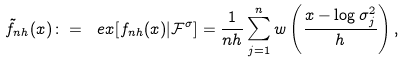Convert formula to latex. <formula><loc_0><loc_0><loc_500><loc_500>\tilde { f } _ { n h } ( x ) \colon = \ e x [ f _ { n h } ( x ) | \mathcal { F } ^ { \sigma } ] = \frac { 1 } { n h } \sum _ { j = 1 } ^ { n } w \left ( \frac { x - \log \sigma ^ { 2 } _ { j } } { h } \right ) ,</formula> 